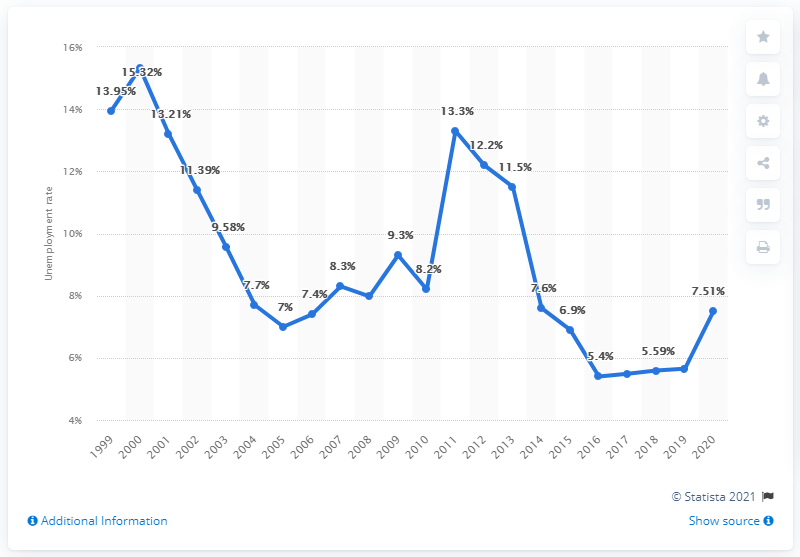Indicate a few pertinent items in this graphic. The unemployment rate in Guam in 2020 was 7.51%. 